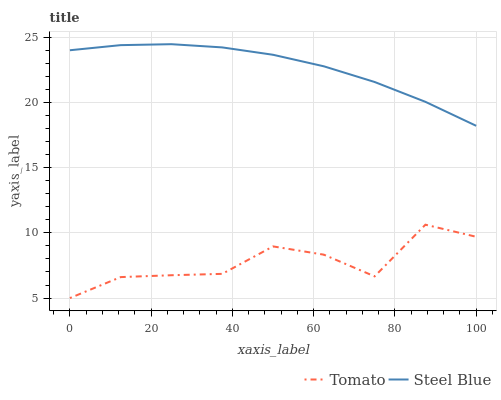Does Tomato have the minimum area under the curve?
Answer yes or no. Yes. Does Steel Blue have the maximum area under the curve?
Answer yes or no. Yes. Does Steel Blue have the minimum area under the curve?
Answer yes or no. No. Is Steel Blue the smoothest?
Answer yes or no. Yes. Is Tomato the roughest?
Answer yes or no. Yes. Is Steel Blue the roughest?
Answer yes or no. No. Does Tomato have the lowest value?
Answer yes or no. Yes. Does Steel Blue have the lowest value?
Answer yes or no. No. Does Steel Blue have the highest value?
Answer yes or no. Yes. Is Tomato less than Steel Blue?
Answer yes or no. Yes. Is Steel Blue greater than Tomato?
Answer yes or no. Yes. Does Tomato intersect Steel Blue?
Answer yes or no. No. 